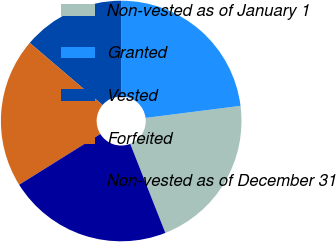<chart> <loc_0><loc_0><loc_500><loc_500><pie_chart><fcel>Non-vested as of January 1<fcel>Granted<fcel>Vested<fcel>Forfeited<fcel>Non-vested as of December 31<nl><fcel>21.03%<fcel>22.99%<fcel>13.75%<fcel>20.14%<fcel>22.1%<nl></chart> 